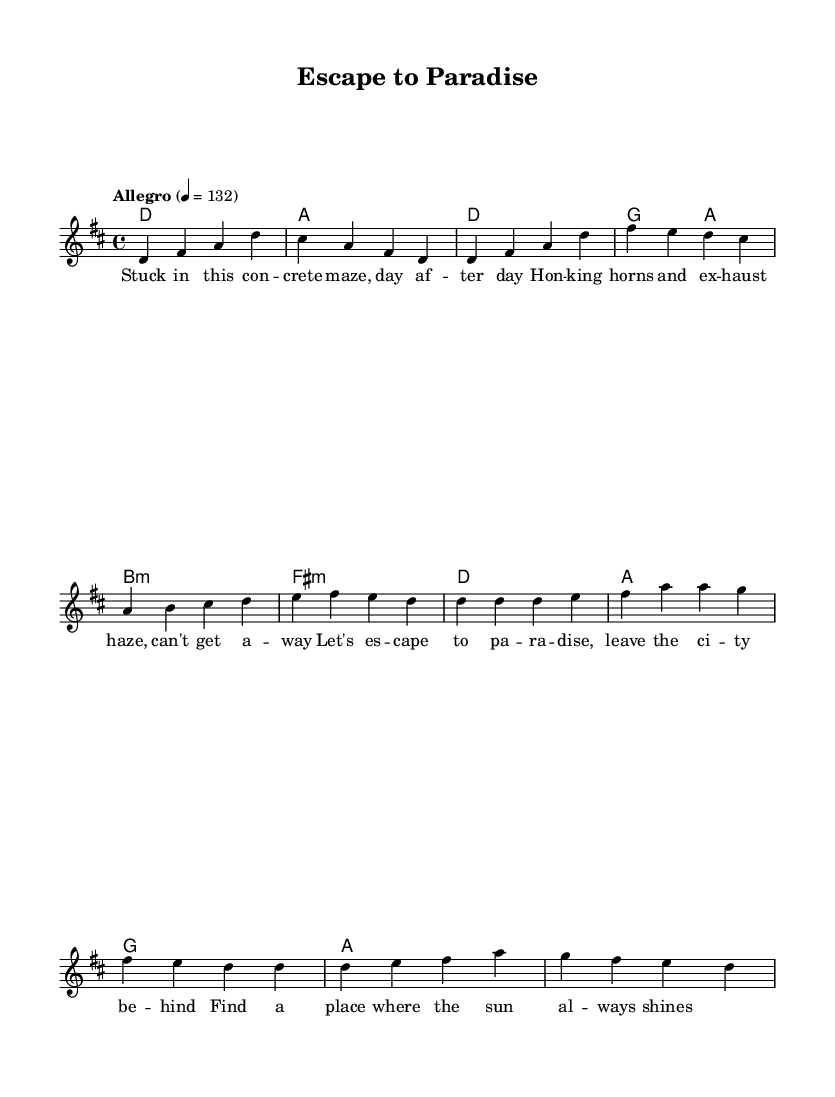What is the key signature of this music? The key signature is D major, which has two sharps (F# and C#). This is indicated at the beginning of the score.
Answer: D major What is the time signature of this music? The time signature is 4/4, which means there are four beats in each measure and the quarter note gets one beat. This is shown at the start of the score as well.
Answer: 4/4 What is the tempo marking of this music? The tempo marking is Allegro, which indicates a fast pace. The actual metronome marking is indicated as 132 beats per minute.
Answer: Allegro How many measures are in the intro section? The intro section consists of two measures, as we can count the measures notated before the verse begins.
Answer: 2 What is the mood suggested by the lyrics in the chorus? The mood suggested by the lyrics is optimistic and adventurous, as they express a desire to escape to a paradise away from the city.
Answer: Optimistic What type of chords are present in the verse section? The chords in the verse section include a mix of major and minor chords, specifically D major, G major, B minor, and F# minor. This variety contributes to the upbeat flavor of the music.
Answer: Major and minor What lyrical theme is expressed in the song? The lyrical theme expressed in the song revolves around the desire to escape from busy city life and go to a place where one can relax and enjoy the sun. This can be inferred from both the verse and chorus lyrics.
Answer: Escaping city life 